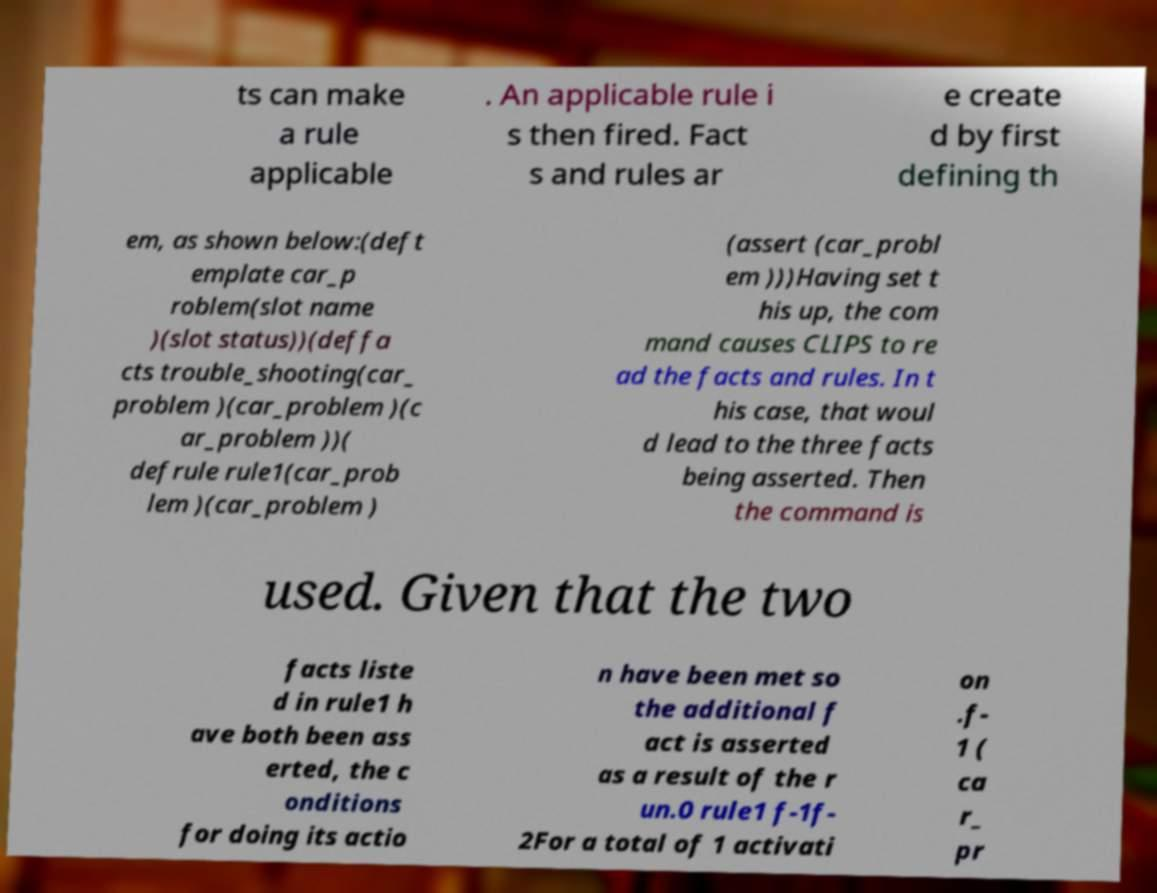What messages or text are displayed in this image? I need them in a readable, typed format. ts can make a rule applicable . An applicable rule i s then fired. Fact s and rules ar e create d by first defining th em, as shown below:(deft emplate car_p roblem(slot name )(slot status))(deffa cts trouble_shooting(car_ problem )(car_problem )(c ar_problem ))( defrule rule1(car_prob lem )(car_problem ) (assert (car_probl em )))Having set t his up, the com mand causes CLIPS to re ad the facts and rules. In t his case, that woul d lead to the three facts being asserted. Then the command is used. Given that the two facts liste d in rule1 h ave both been ass erted, the c onditions for doing its actio n have been met so the additional f act is asserted as a result of the r un.0 rule1 f-1f- 2For a total of 1 activati on .f- 1 ( ca r_ pr 